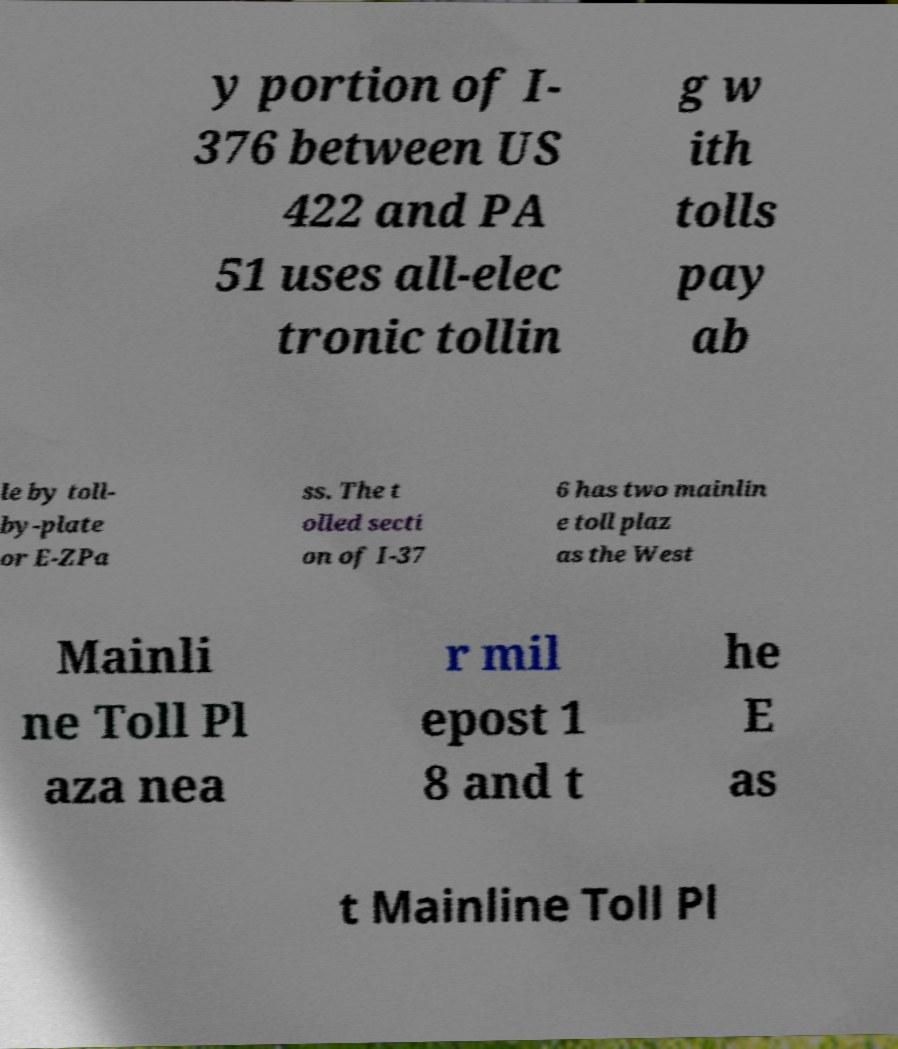Please read and relay the text visible in this image. What does it say? y portion of I- 376 between US 422 and PA 51 uses all-elec tronic tollin g w ith tolls pay ab le by toll- by-plate or E-ZPa ss. The t olled secti on of I-37 6 has two mainlin e toll plaz as the West Mainli ne Toll Pl aza nea r mil epost 1 8 and t he E as t Mainline Toll Pl 